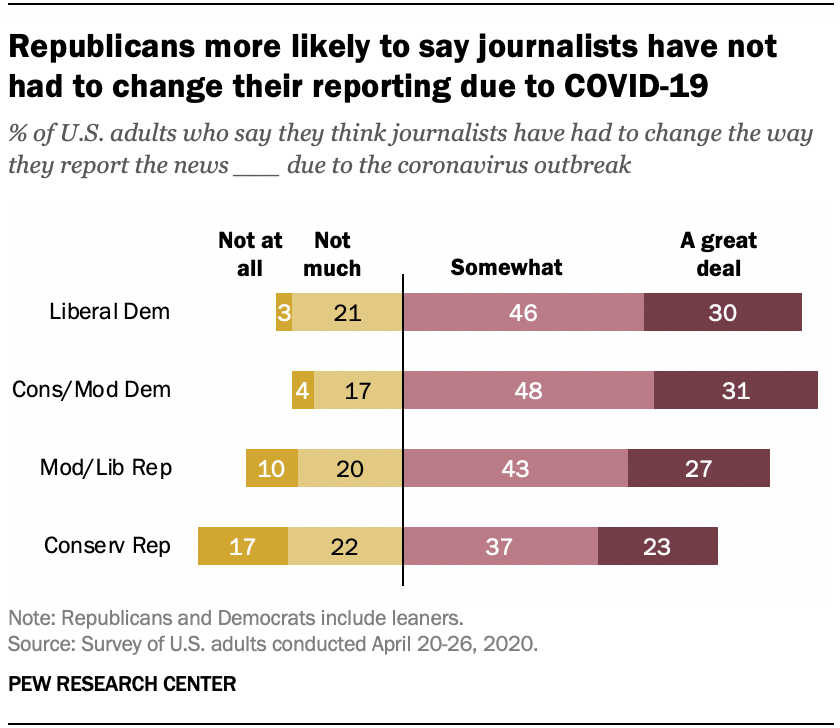Give some essential details in this illustration. A significant number of adults in the United States, who believe that journalists have had to adjust the way they report the news due to the COVID-19 pandemic, value the principles of the Liberal Democrats. 